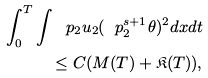<formula> <loc_0><loc_0><loc_500><loc_500>\int _ { 0 } ^ { T } \int \ p _ { 2 } u _ { 2 } ( \ p _ { 2 } ^ { s + 1 } \theta ) ^ { 2 } d x d t \\ \leq C ( M ( T ) + \mathfrak { K } ( T ) ) ,</formula> 